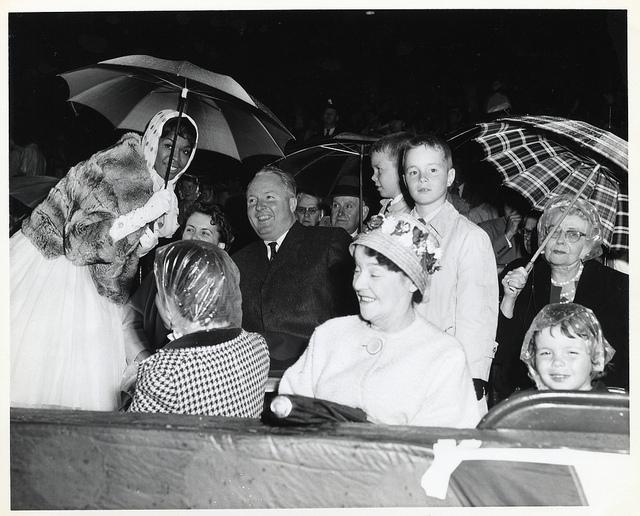IS this picture in black and white?
Write a very short answer. Yes. Are there any elderly people in the picture?
Give a very brief answer. Yes. Do the people look happy?
Keep it brief. Yes. 